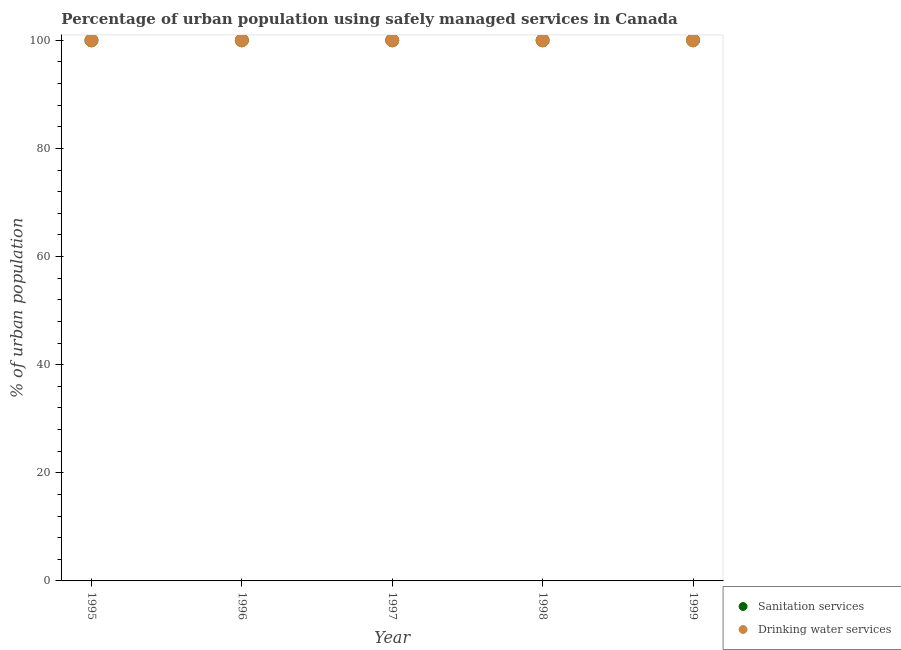How many different coloured dotlines are there?
Your response must be concise. 2. What is the percentage of urban population who used drinking water services in 1999?
Ensure brevity in your answer.  100. Across all years, what is the maximum percentage of urban population who used sanitation services?
Provide a short and direct response. 100. Across all years, what is the minimum percentage of urban population who used sanitation services?
Your answer should be compact. 100. What is the total percentage of urban population who used sanitation services in the graph?
Your answer should be very brief. 500. In how many years, is the percentage of urban population who used drinking water services greater than 92 %?
Ensure brevity in your answer.  5. What is the ratio of the percentage of urban population who used drinking water services in 1995 to that in 1999?
Your response must be concise. 1. Is the percentage of urban population who used drinking water services in 1997 less than that in 1999?
Offer a very short reply. No. Is the difference between the percentage of urban population who used sanitation services in 1997 and 1999 greater than the difference between the percentage of urban population who used drinking water services in 1997 and 1999?
Make the answer very short. No. In how many years, is the percentage of urban population who used drinking water services greater than the average percentage of urban population who used drinking water services taken over all years?
Your answer should be compact. 0. Is the sum of the percentage of urban population who used drinking water services in 1995 and 1996 greater than the maximum percentage of urban population who used sanitation services across all years?
Provide a short and direct response. Yes. Does the percentage of urban population who used drinking water services monotonically increase over the years?
Your response must be concise. No. Is the percentage of urban population who used sanitation services strictly greater than the percentage of urban population who used drinking water services over the years?
Your answer should be very brief. No. How many years are there in the graph?
Offer a terse response. 5. What is the difference between two consecutive major ticks on the Y-axis?
Provide a short and direct response. 20. Does the graph contain any zero values?
Ensure brevity in your answer.  No. How many legend labels are there?
Ensure brevity in your answer.  2. What is the title of the graph?
Make the answer very short. Percentage of urban population using safely managed services in Canada. What is the label or title of the X-axis?
Provide a succinct answer. Year. What is the label or title of the Y-axis?
Your answer should be very brief. % of urban population. What is the % of urban population in Sanitation services in 1996?
Provide a short and direct response. 100. What is the % of urban population in Drinking water services in 1996?
Ensure brevity in your answer.  100. What is the % of urban population of Sanitation services in 1997?
Provide a succinct answer. 100. What is the % of urban population in Drinking water services in 1997?
Ensure brevity in your answer.  100. What is the % of urban population in Drinking water services in 1998?
Your answer should be very brief. 100. What is the % of urban population in Sanitation services in 1999?
Your response must be concise. 100. Across all years, what is the minimum % of urban population of Drinking water services?
Provide a succinct answer. 100. What is the total % of urban population in Drinking water services in the graph?
Ensure brevity in your answer.  500. What is the difference between the % of urban population in Sanitation services in 1995 and that in 1998?
Offer a terse response. 0. What is the difference between the % of urban population of Drinking water services in 1995 and that in 1998?
Make the answer very short. 0. What is the difference between the % of urban population of Sanitation services in 1995 and that in 1999?
Give a very brief answer. 0. What is the difference between the % of urban population in Sanitation services in 1996 and that in 1997?
Your answer should be compact. 0. What is the difference between the % of urban population in Drinking water services in 1996 and that in 1997?
Make the answer very short. 0. What is the difference between the % of urban population of Sanitation services in 1996 and that in 1999?
Offer a terse response. 0. What is the difference between the % of urban population in Drinking water services in 1996 and that in 1999?
Make the answer very short. 0. What is the difference between the % of urban population in Sanitation services in 1997 and that in 1998?
Your response must be concise. 0. What is the difference between the % of urban population of Drinking water services in 1997 and that in 1999?
Your answer should be compact. 0. What is the difference between the % of urban population in Sanitation services in 1998 and that in 1999?
Your answer should be compact. 0. What is the difference between the % of urban population of Drinking water services in 1998 and that in 1999?
Your answer should be very brief. 0. What is the difference between the % of urban population of Sanitation services in 1995 and the % of urban population of Drinking water services in 1997?
Your answer should be very brief. 0. What is the difference between the % of urban population of Sanitation services in 1995 and the % of urban population of Drinking water services in 1999?
Provide a succinct answer. 0. What is the difference between the % of urban population in Sanitation services in 1996 and the % of urban population in Drinking water services in 1997?
Provide a short and direct response. 0. What is the difference between the % of urban population of Sanitation services in 1996 and the % of urban population of Drinking water services in 1998?
Offer a terse response. 0. What is the difference between the % of urban population in Sanitation services in 1997 and the % of urban population in Drinking water services in 1998?
Provide a short and direct response. 0. What is the difference between the % of urban population of Sanitation services in 1997 and the % of urban population of Drinking water services in 1999?
Keep it short and to the point. 0. What is the average % of urban population in Drinking water services per year?
Your answer should be very brief. 100. In the year 1995, what is the difference between the % of urban population of Sanitation services and % of urban population of Drinking water services?
Your response must be concise. 0. In the year 1999, what is the difference between the % of urban population of Sanitation services and % of urban population of Drinking water services?
Give a very brief answer. 0. What is the ratio of the % of urban population in Sanitation services in 1995 to that in 1996?
Provide a short and direct response. 1. What is the ratio of the % of urban population of Sanitation services in 1995 to that in 1997?
Offer a very short reply. 1. What is the ratio of the % of urban population of Sanitation services in 1995 to that in 1998?
Give a very brief answer. 1. What is the ratio of the % of urban population in Sanitation services in 1995 to that in 1999?
Provide a succinct answer. 1. What is the ratio of the % of urban population of Sanitation services in 1996 to that in 1998?
Keep it short and to the point. 1. What is the ratio of the % of urban population in Drinking water services in 1996 to that in 1998?
Your answer should be very brief. 1. What is the ratio of the % of urban population of Sanitation services in 1996 to that in 1999?
Provide a short and direct response. 1. What is the ratio of the % of urban population in Sanitation services in 1997 to that in 1998?
Provide a succinct answer. 1. What is the ratio of the % of urban population of Drinking water services in 1998 to that in 1999?
Your answer should be very brief. 1. What is the difference between the highest and the second highest % of urban population of Sanitation services?
Your response must be concise. 0. What is the difference between the highest and the second highest % of urban population of Drinking water services?
Your response must be concise. 0. What is the difference between the highest and the lowest % of urban population of Drinking water services?
Offer a very short reply. 0. 